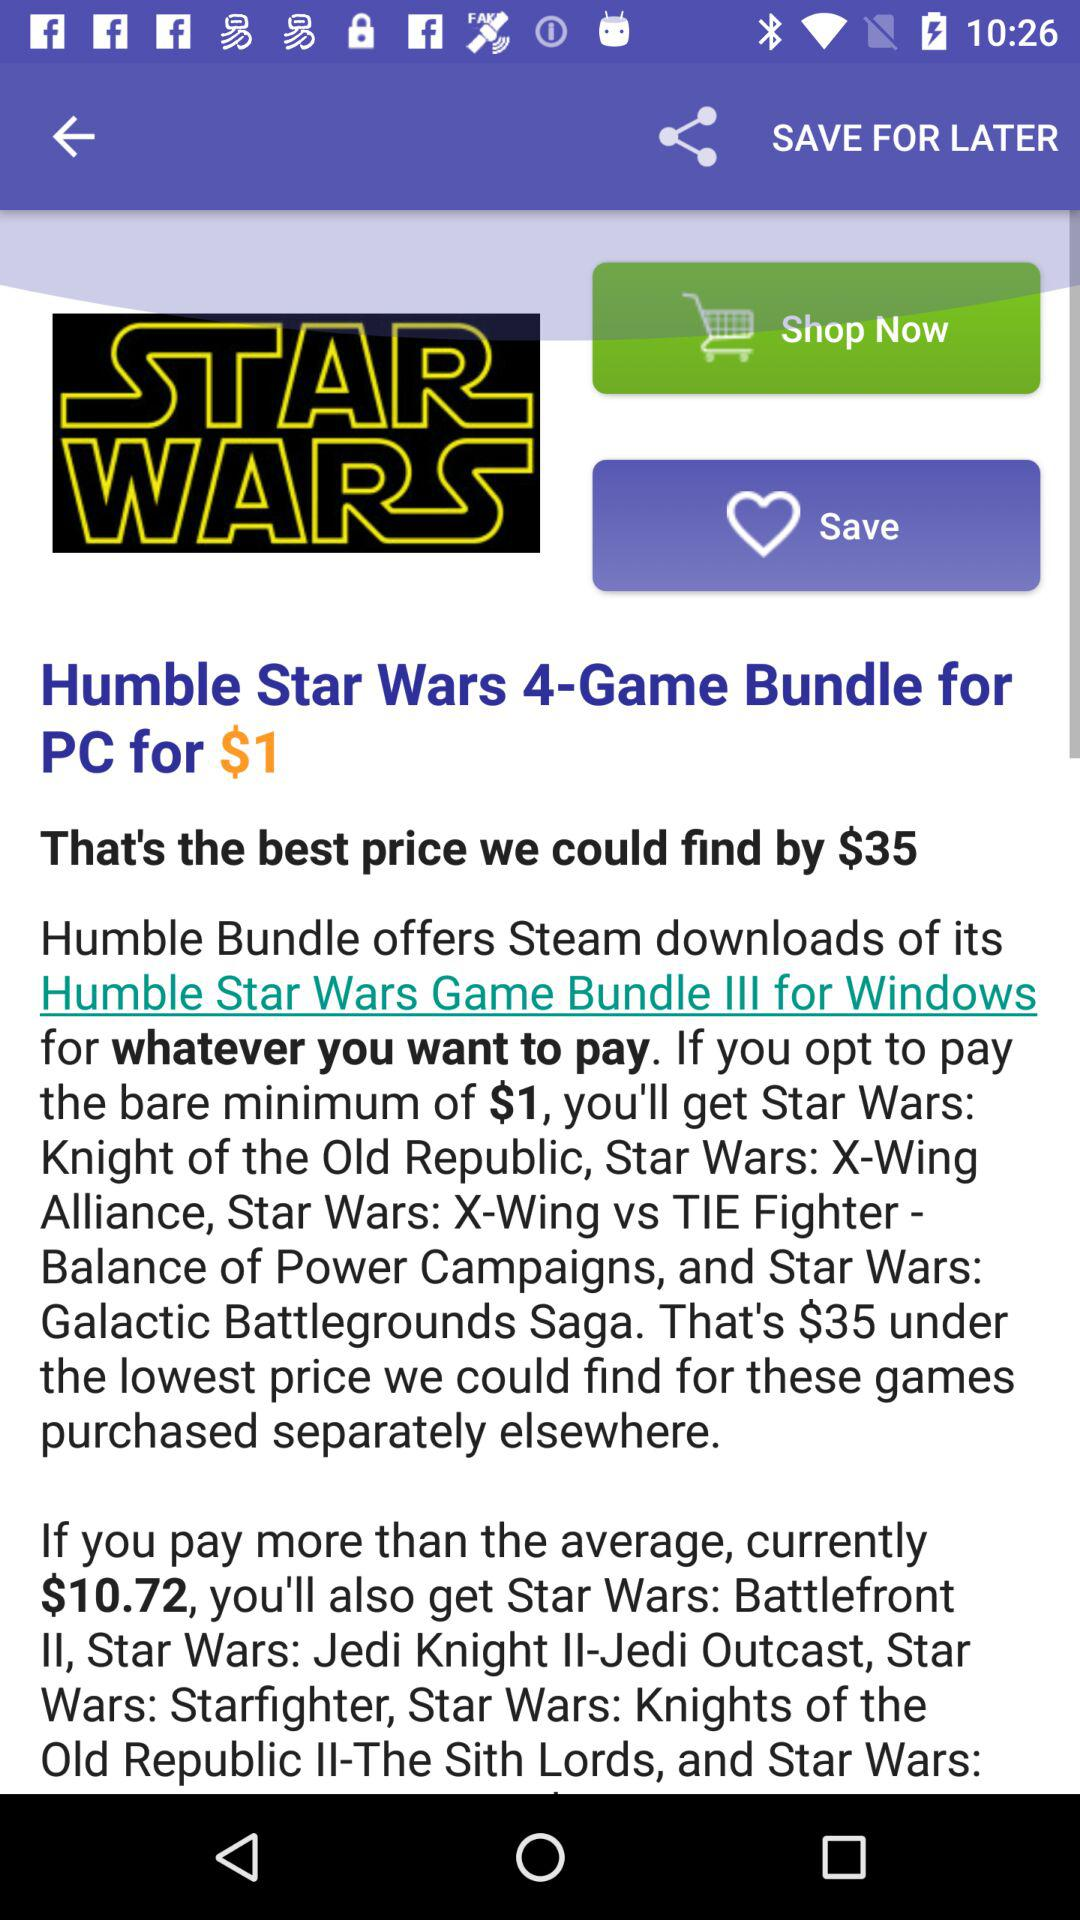How many items are in the cart?
When the provided information is insufficient, respond with <no answer>. <no answer> 